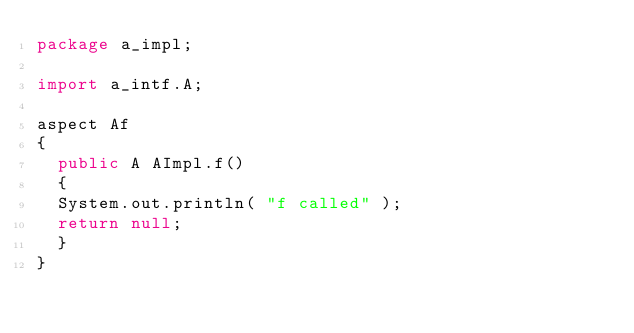Convert code to text. <code><loc_0><loc_0><loc_500><loc_500><_Java_>package a_impl;

import a_intf.A;

aspect Af
{
  public A AImpl.f()
  {
	System.out.println( "f called" );
	return null;
  }
}
</code> 